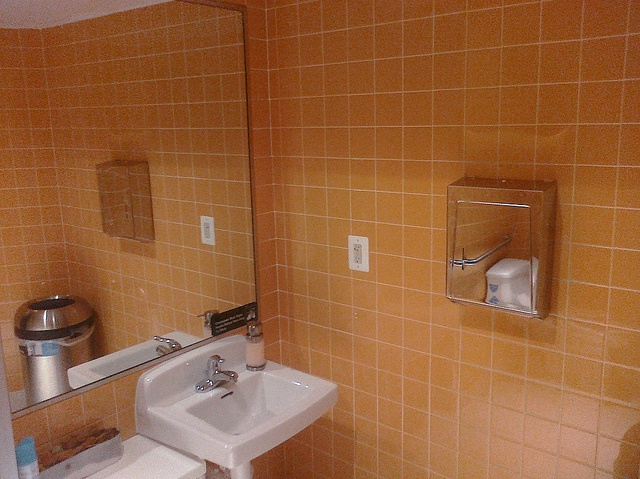Describe the objects in this image and their specific colors. I can see sink in gray and darkgray tones, toilet in gray, darkgray, and lightgray tones, sink in gray and darkgray tones, toilet in gray and darkgray tones, and bottle in gray and maroon tones in this image. 